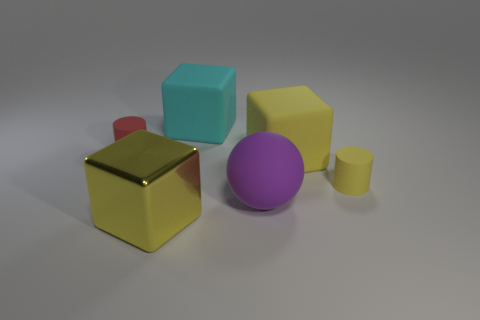Subtract all matte cubes. How many cubes are left? 1 Subtract 1 cylinders. How many cylinders are left? 1 Add 1 big purple objects. How many objects exist? 7 Subtract all spheres. How many objects are left? 5 Subtract all yellow matte things. Subtract all yellow rubber objects. How many objects are left? 2 Add 6 large yellow metal things. How many large yellow metal things are left? 7 Add 6 big yellow things. How many big yellow things exist? 8 Subtract all cyan cubes. How many cubes are left? 2 Subtract 1 purple balls. How many objects are left? 5 Subtract all green cylinders. Subtract all blue spheres. How many cylinders are left? 2 